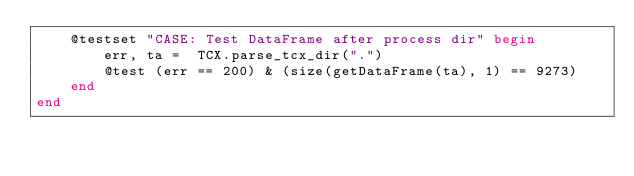Convert code to text. <code><loc_0><loc_0><loc_500><loc_500><_Julia_>    @testset "CASE: Test DataFrame after process dir" begin
        err, ta =  TCX.parse_tcx_dir(".")
        @test (err == 200) & (size(getDataFrame(ta), 1) == 9273)
    end
end

</code> 